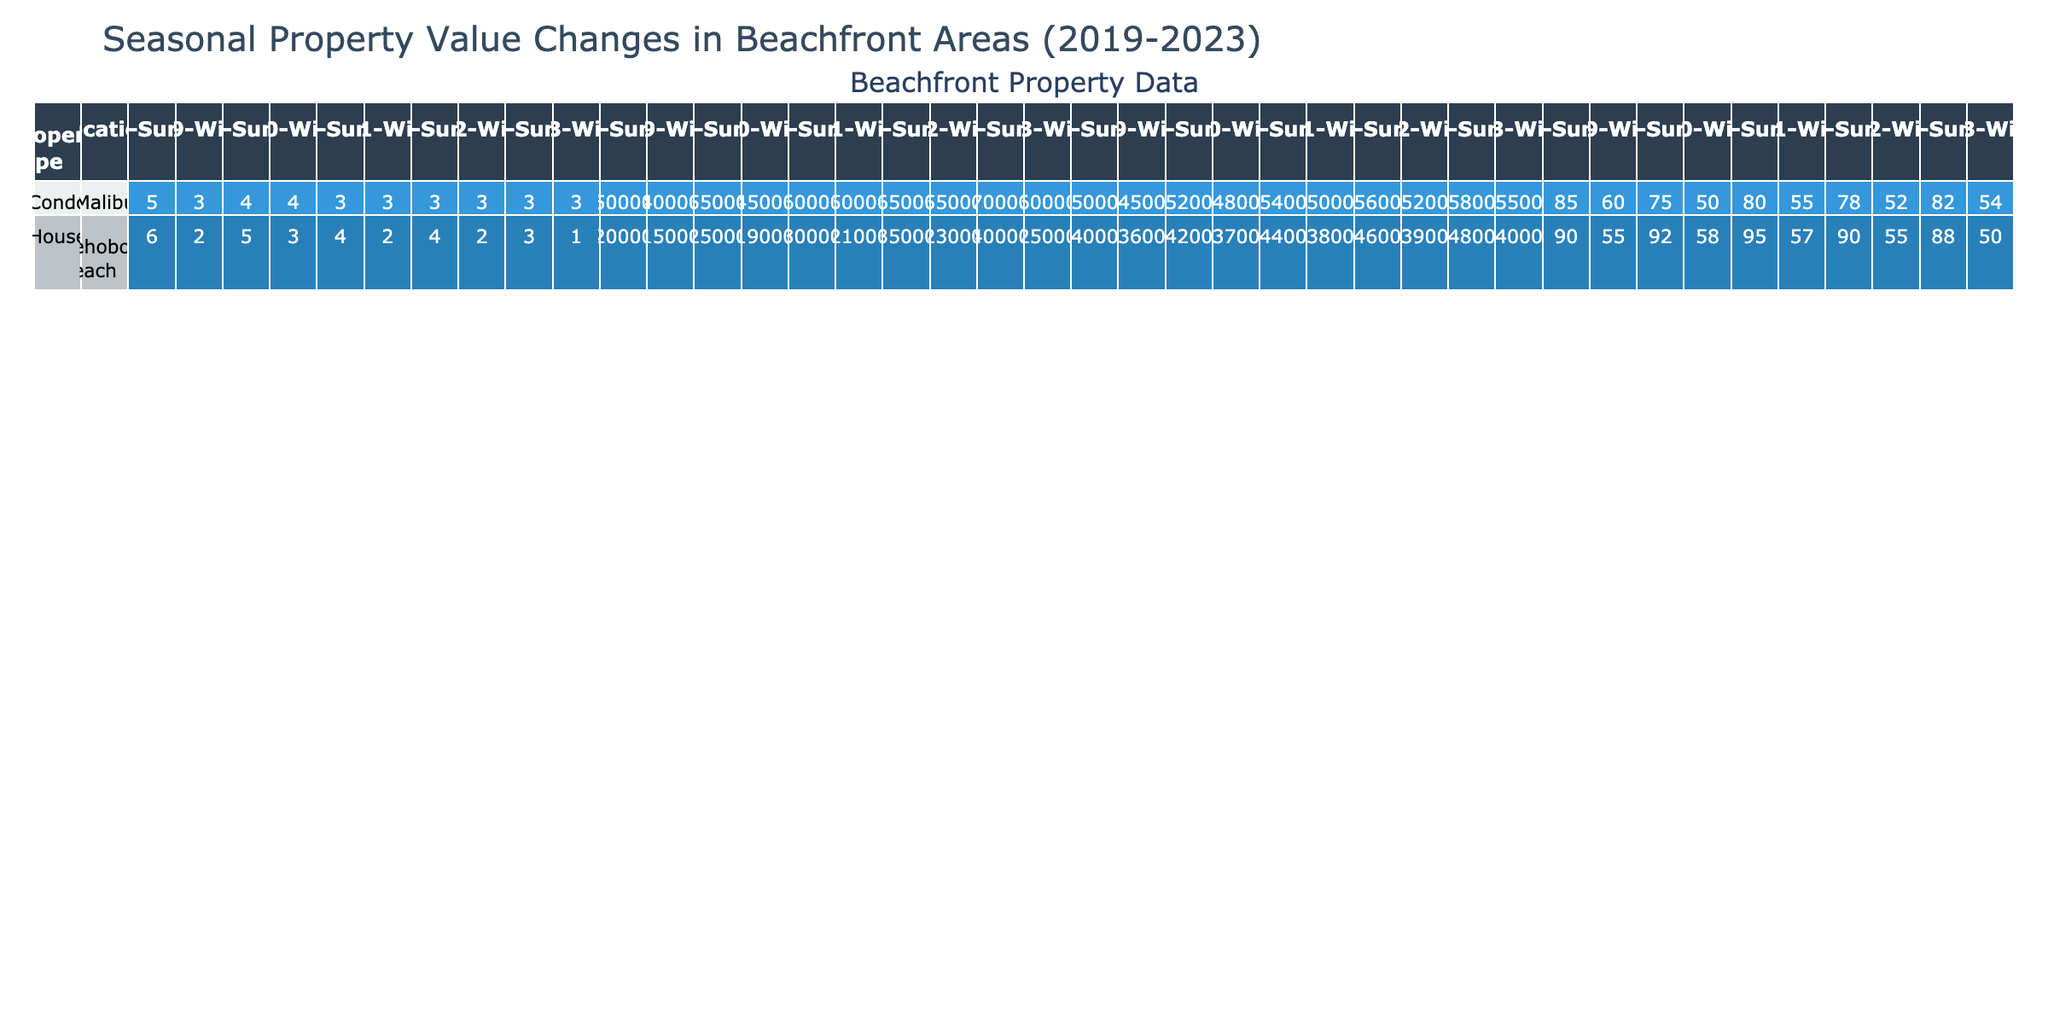What was the average property value of condos in Malibu during summer 2021? The average property value for condos in Malibu during summer 2021 is listed directly in the table under that specific row and column, which reads 1,600,000.
Answer: 1,600,000 What is the occupancy rate for houses in Rehoboth Beach during winter 2023? Similar to the previous question, the occupancy rate for houses in Rehoboth Beach during winter 2023 can be found directly in the table, which states 50%.
Answer: 50% What was the annual growth rate for condos in Malibu from winter 2022 to summer 2023? From winter 2022, the average property value for condos in Malibu was 1,550,000, and in summer 2023 it was 1,700,000. The annual growth rate is calculated by finding the difference (1,700,000 - 1,550,000 = 150,000), then dividing by the winter 2022 value and multiplying by 100, giving (150,000 / 1,550,000) * 100 = 9.68%, which is typically rounded to 10% for reporting.
Answer: 10% Is the median rental price for summer houses in Rehoboth Beach always higher than the median rental price for winter houses during the last five years? We compare the median rental prices for summer and winter houses in Rehoboth Beach across all five years. In 2019, summer was 4,000 and winter was 3,600; in 2020, summer was 4,200 and winter was 3,700; in 2021, summer was 4,400 and winter was 3,800; in 2022, summer was 4,600 and winter was 3,900; and in 2023, summer was 4,800 and winter was 4,000. All summer prices are higher, confirming that it is always higher.
Answer: Yes Calculate the total average property value growth for houses in Rehoboth Beach from 2019 winter to 2023 summer. The average property values for houses in Rehoboth Beach from winter 2019 to summer 2023 are 1,150,000 and 1,400,000, respectively. The growth is calculated by finding the difference (1,400,000 - 1,150,000 = 250,000), thus the total growth over these years is 250,000.
Answer: 250,000 During which season in 2022 did condos in Malibu have the highest average property value? Looking at the average property values for condos in Malibu throughout 2022, summer shows an average of 1,650,000, while winter shows 1,550,000. Therefore, summer had the highest average property value.
Answer: Summer 2022 What was the median rental price for houses in Rehoboth Beach in Summer 2022? This value is explicitly listed in the table under the summer 2022 row for houses, which states the median rental price is 4,600.
Answer: 4,600 Is the average property value for Malibu condos declining over the last five years? Evaluating the average property values for Malibu condos over the years starting from 2019 shows they have generally risen (1,500,000 in 2019, 1,550,000 in 2020, 1,600,000 in 2021, 1,650,000 in 2022, and reaching 1,700,000 in 2023). Hence, the average property value is not declining but increasing.
Answer: No 